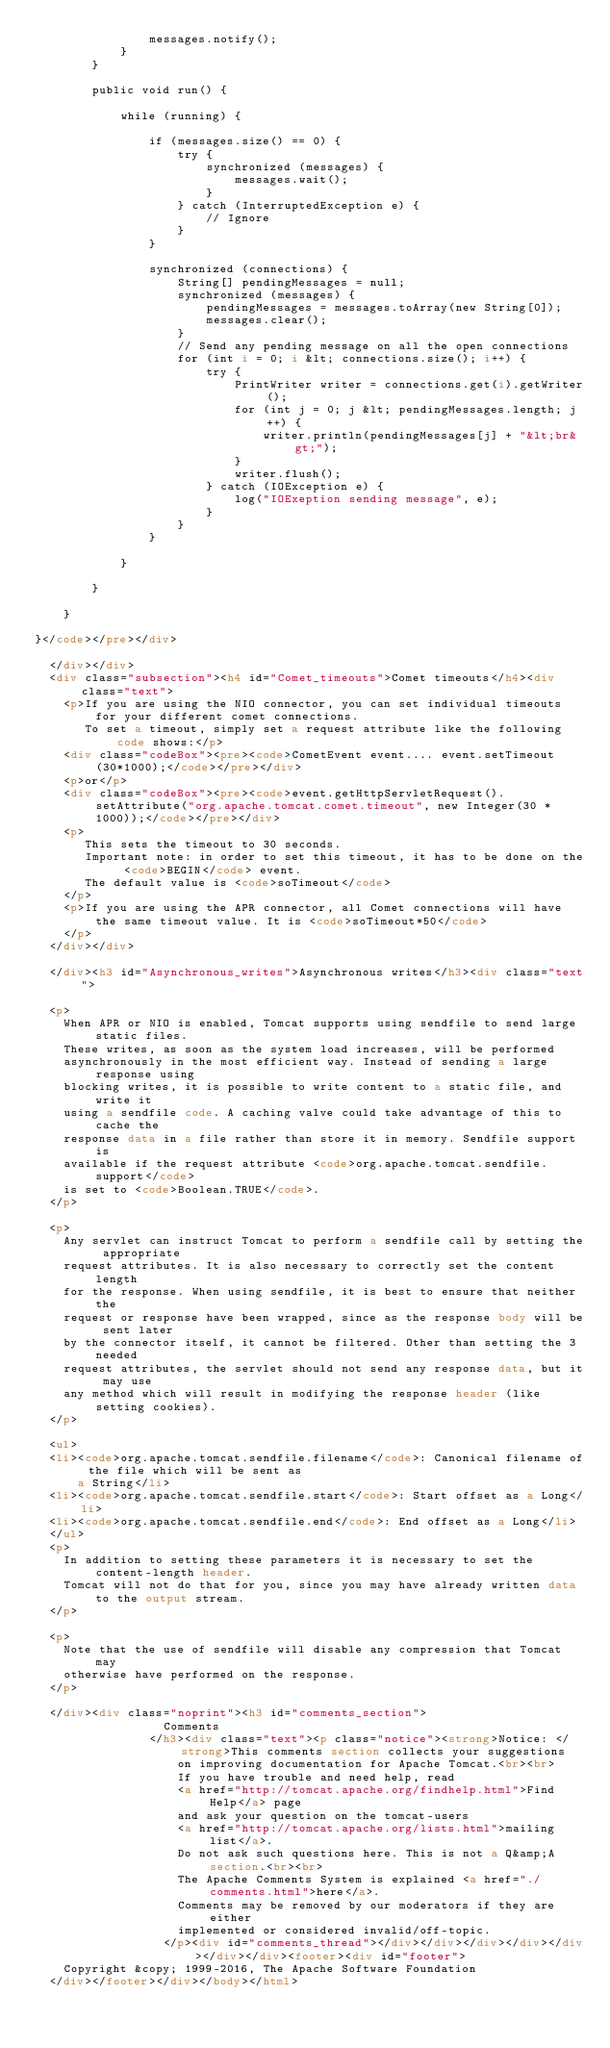<code> <loc_0><loc_0><loc_500><loc_500><_HTML_>                messages.notify();
            }
        }

        public void run() {

            while (running) {

                if (messages.size() == 0) {
                    try {
                        synchronized (messages) {
                            messages.wait();
                        }
                    } catch (InterruptedException e) {
                        // Ignore
                    }
                }

                synchronized (connections) {
                    String[] pendingMessages = null;
                    synchronized (messages) {
                        pendingMessages = messages.toArray(new String[0]);
                        messages.clear();
                    }
                    // Send any pending message on all the open connections
                    for (int i = 0; i &lt; connections.size(); i++) {
                        try {
                            PrintWriter writer = connections.get(i).getWriter();
                            for (int j = 0; j &lt; pendingMessages.length; j++) {
                                writer.println(pendingMessages[j] + "&lt;br&gt;");
                            }
                            writer.flush();
                        } catch (IOException e) {
                            log("IOExeption sending message", e);
                        }
                    }
                }

            }

        }

    }

}</code></pre></div>

  </div></div>
  <div class="subsection"><h4 id="Comet_timeouts">Comet timeouts</h4><div class="text">
    <p>If you are using the NIO connector, you can set individual timeouts for your different comet connections.
       To set a timeout, simply set a request attribute like the following code shows:</p>
    <div class="codeBox"><pre><code>CometEvent event.... event.setTimeout(30*1000);</code></pre></div>
    <p>or</p>
    <div class="codeBox"><pre><code>event.getHttpServletRequest().setAttribute("org.apache.tomcat.comet.timeout", new Integer(30 * 1000));</code></pre></div>
    <p>
       This sets the timeout to 30 seconds.
       Important note: in order to set this timeout, it has to be done on the <code>BEGIN</code> event.
       The default value is <code>soTimeout</code>
    </p>
    <p>If you are using the APR connector, all Comet connections will have the same timeout value. It is <code>soTimeout*50</code>
    </p>
  </div></div>

  </div><h3 id="Asynchronous_writes">Asynchronous writes</h3><div class="text">

  <p>
    When APR or NIO is enabled, Tomcat supports using sendfile to send large static files.
    These writes, as soon as the system load increases, will be performed
    asynchronously in the most efficient way. Instead of sending a large response using
    blocking writes, it is possible to write content to a static file, and write it
    using a sendfile code. A caching valve could take advantage of this to cache the
    response data in a file rather than store it in memory. Sendfile support is
    available if the request attribute <code>org.apache.tomcat.sendfile.support</code>
    is set to <code>Boolean.TRUE</code>.
  </p>

  <p>
    Any servlet can instruct Tomcat to perform a sendfile call by setting the appropriate
    request attributes. It is also necessary to correctly set the content length
    for the response. When using sendfile, it is best to ensure that neither the
    request or response have been wrapped, since as the response body will be sent later
    by the connector itself, it cannot be filtered. Other than setting the 3 needed
    request attributes, the servlet should not send any response data, but it may use
    any method which will result in modifying the response header (like setting cookies).
  </p>

  <ul>
  <li><code>org.apache.tomcat.sendfile.filename</code>: Canonical filename of the file which will be sent as
      a String</li>
  <li><code>org.apache.tomcat.sendfile.start</code>: Start offset as a Long</li>
  <li><code>org.apache.tomcat.sendfile.end</code>: End offset as a Long</li>
  </ul>
  <p>
    In addition to setting these parameters it is necessary to set the content-length header.
    Tomcat will not do that for you, since you may have already written data to the output stream.
  </p>

  <p>
    Note that the use of sendfile will disable any compression that Tomcat may
    otherwise have performed on the response.
  </p>

  </div><div class="noprint"><h3 id="comments_section">
                  Comments
                </h3><div class="text"><p class="notice"><strong>Notice: </strong>This comments section collects your suggestions
                    on improving documentation for Apache Tomcat.<br><br>
                    If you have trouble and need help, read
                    <a href="http://tomcat.apache.org/findhelp.html">Find Help</a> page
                    and ask your question on the tomcat-users
                    <a href="http://tomcat.apache.org/lists.html">mailing list</a>.
                    Do not ask such questions here. This is not a Q&amp;A section.<br><br>
                    The Apache Comments System is explained <a href="./comments.html">here</a>.
                    Comments may be removed by our moderators if they are either
                    implemented or considered invalid/off-topic.
                  </p><div id="comments_thread"></div></div></div></div></div></div></div><footer><div id="footer">
    Copyright &copy; 1999-2016, The Apache Software Foundation
  </div></footer></div></body></html></code> 